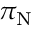Convert formula to latex. <formula><loc_0><loc_0><loc_500><loc_500>\pi _ { N }</formula> 